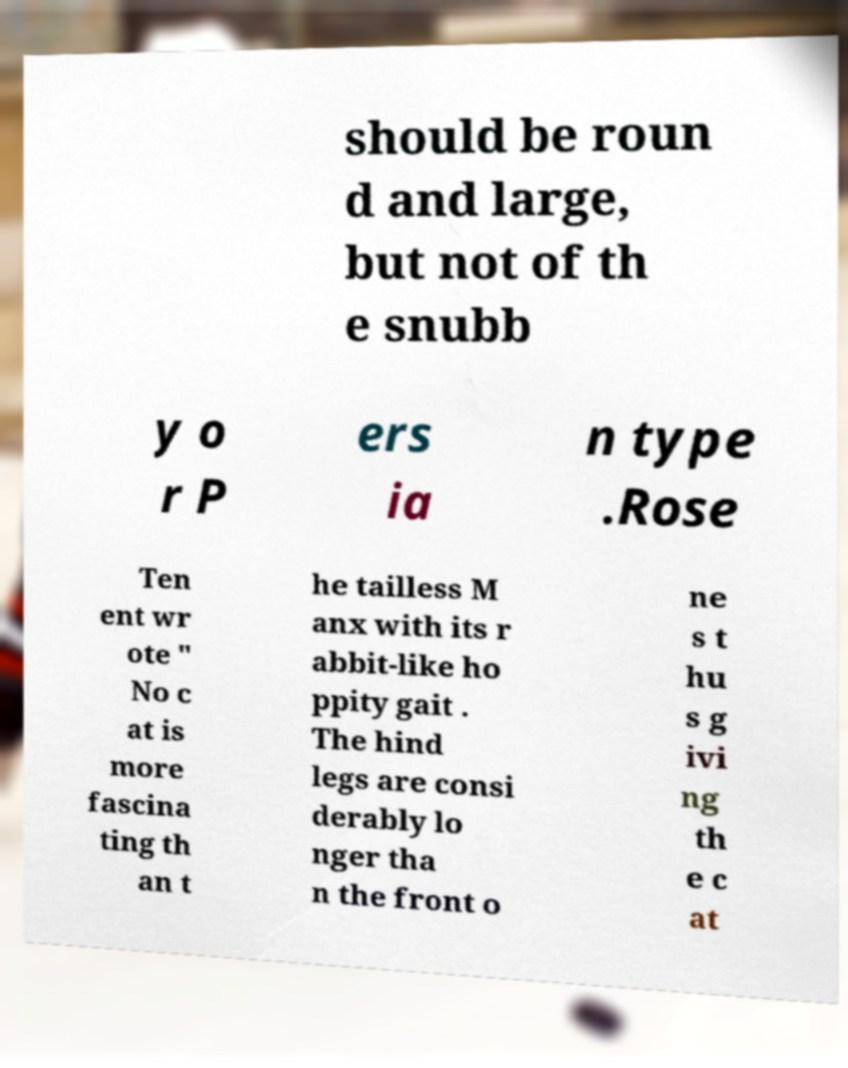Please identify and transcribe the text found in this image. should be roun d and large, but not of th e snubb y o r P ers ia n type .Rose Ten ent wr ote " No c at is more fascina ting th an t he tailless M anx with its r abbit-like ho ppity gait . The hind legs are consi derably lo nger tha n the front o ne s t hu s g ivi ng th e c at 